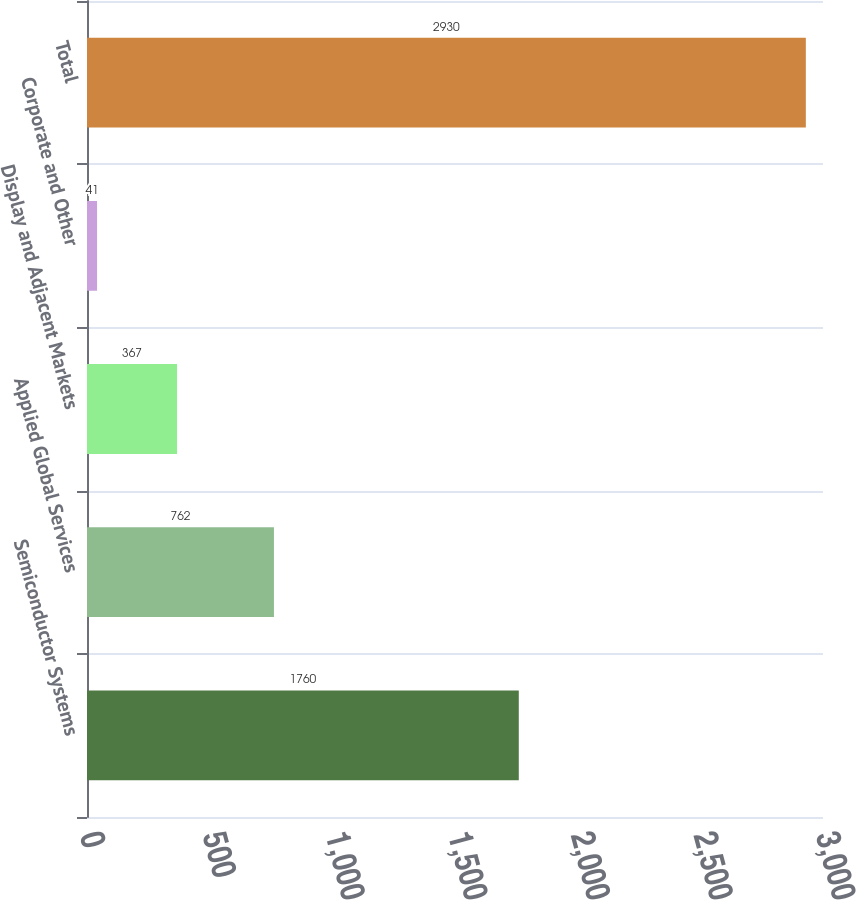Convert chart. <chart><loc_0><loc_0><loc_500><loc_500><bar_chart><fcel>Semiconductor Systems<fcel>Applied Global Services<fcel>Display and Adjacent Markets<fcel>Corporate and Other<fcel>Total<nl><fcel>1760<fcel>762<fcel>367<fcel>41<fcel>2930<nl></chart> 